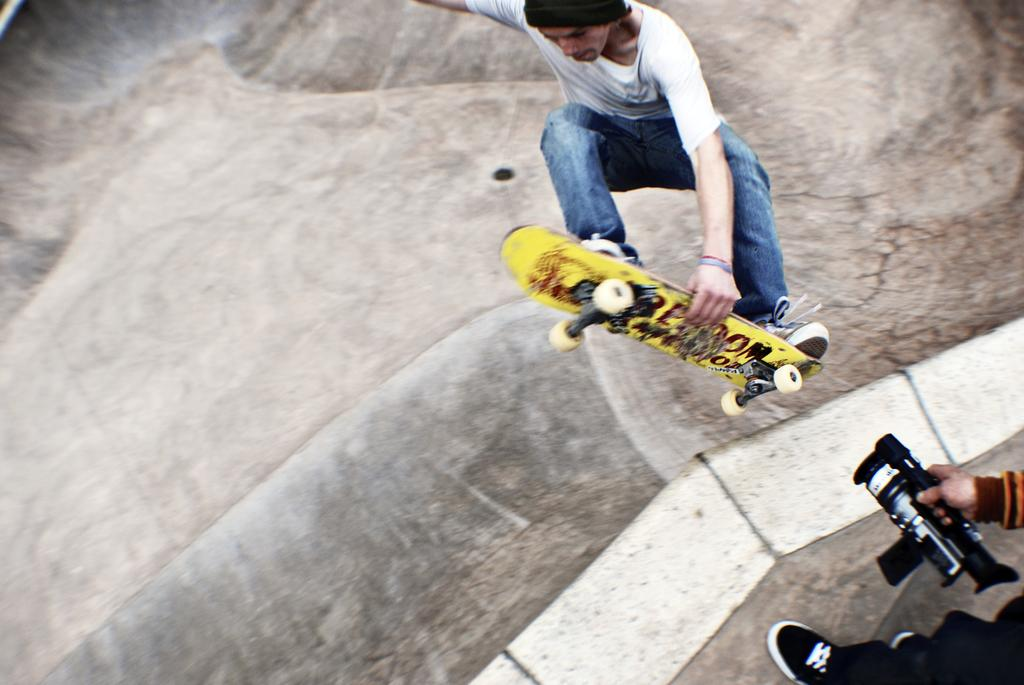What is the main subject of the image? There is a man in the image. What is the man doing in the image? The man is jumping with a skateboard. Can you describe the person on the right side of the image? There is a person holding a camera on the right side of the image. What is visible at the bottom of the image? There is a road at the bottom of the image. How many friends are standing next to the cattle in the image? There are no friends or cattle present in the image. 